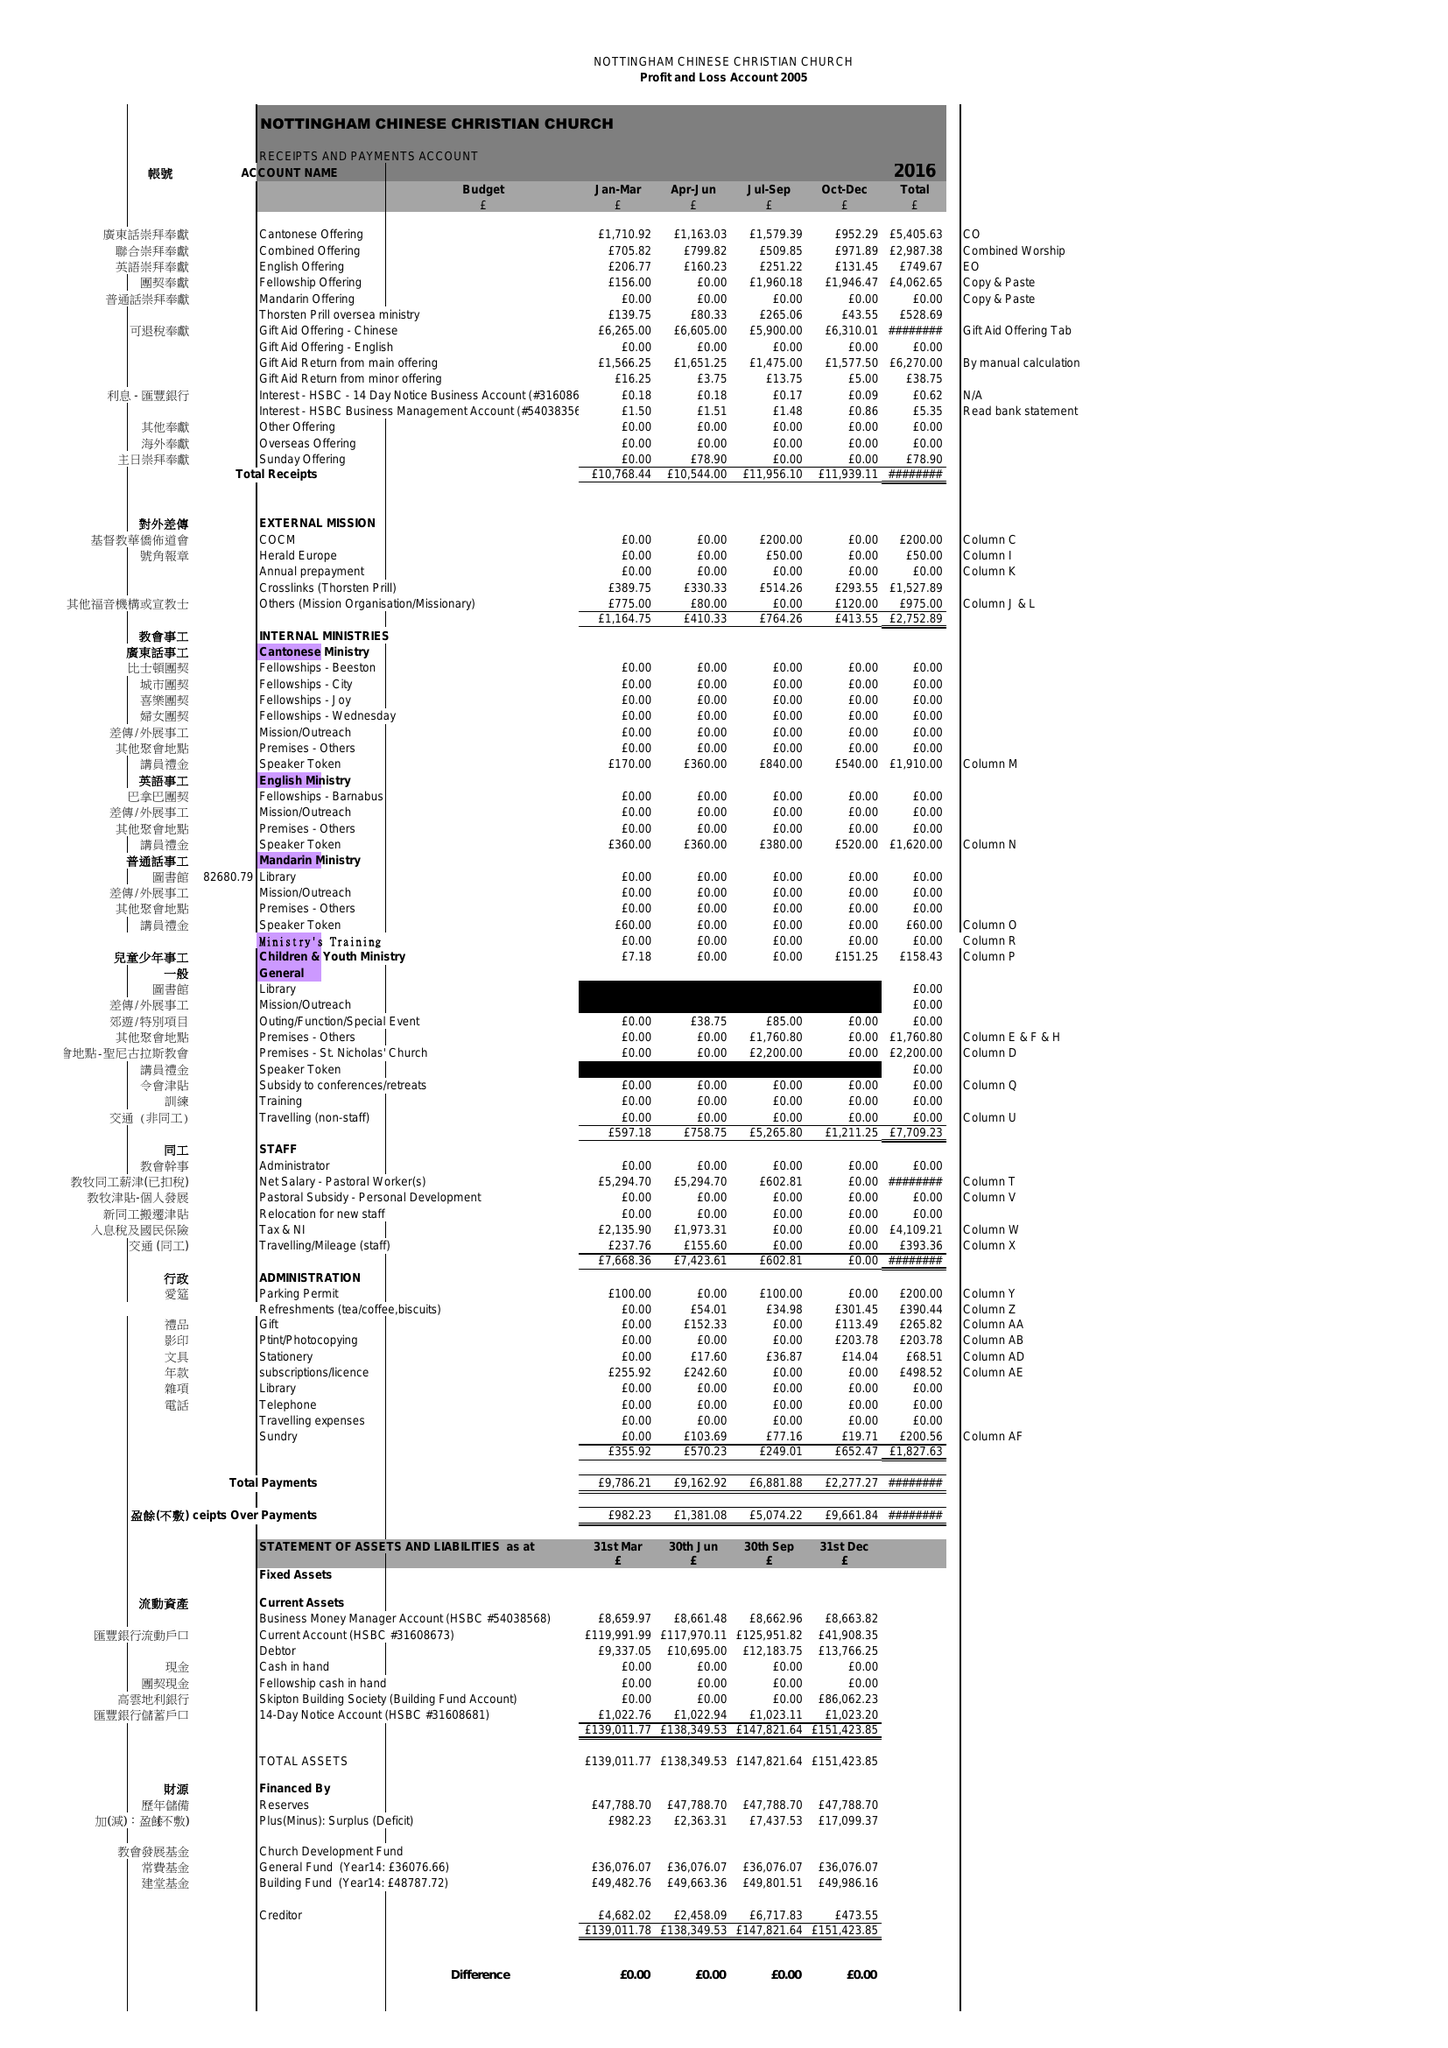What is the value for the address__postcode?
Answer the question using a single word or phrase. NG1 6AE 